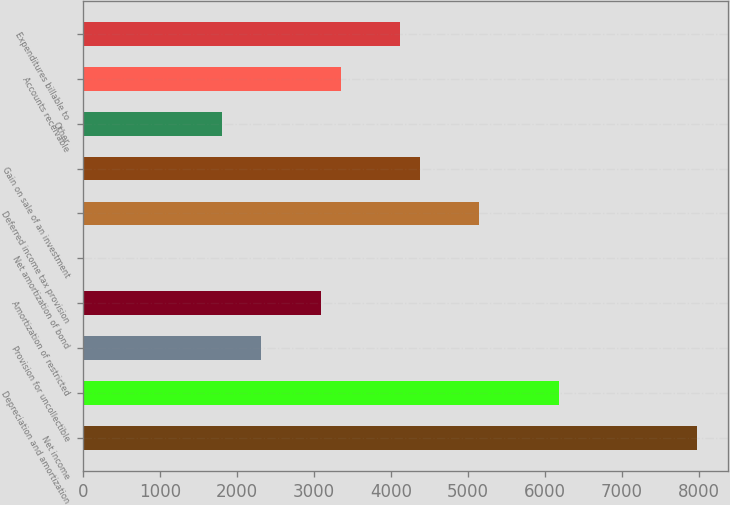Convert chart. <chart><loc_0><loc_0><loc_500><loc_500><bar_chart><fcel>Net income<fcel>Depreciation and amortization<fcel>Provision for uncollectible<fcel>Amortization of restricted<fcel>Net amortization of bond<fcel>Deferred income tax provision<fcel>Gain on sale of an investment<fcel>Other<fcel>Accounts receivable<fcel>Expenditures billable to<nl><fcel>7978.1<fcel>6177<fcel>2317.5<fcel>3089.4<fcel>1.8<fcel>5147.8<fcel>4375.9<fcel>1802.9<fcel>3346.7<fcel>4118.6<nl></chart> 